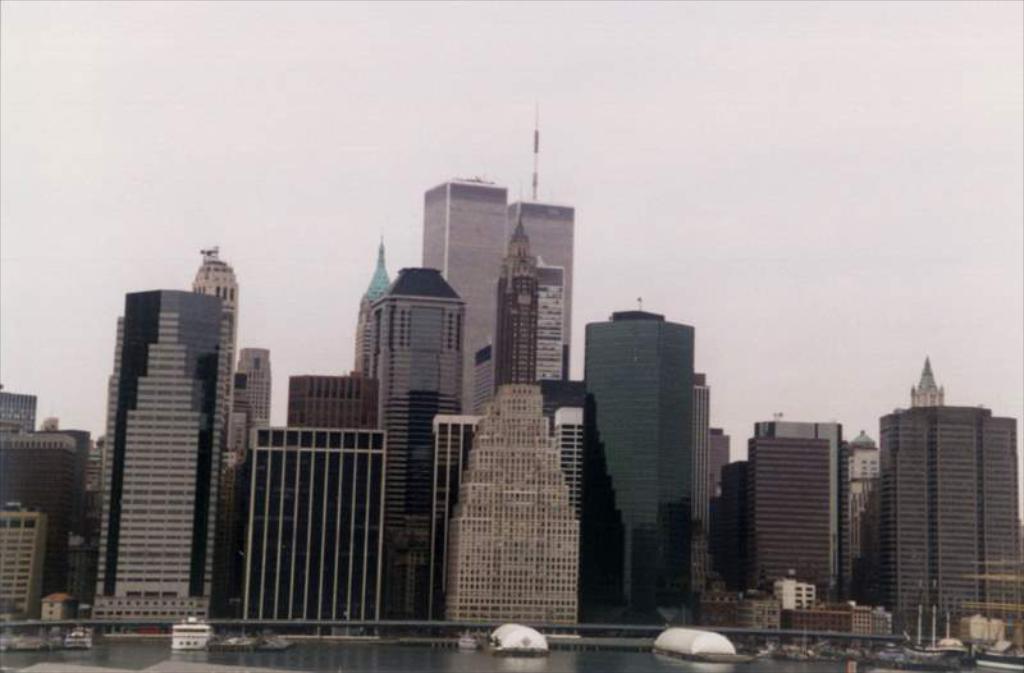Describe this image in one or two sentences. There are many buildings. Near to the buildings there is water. On the water there are boats. In the background there is sky. 